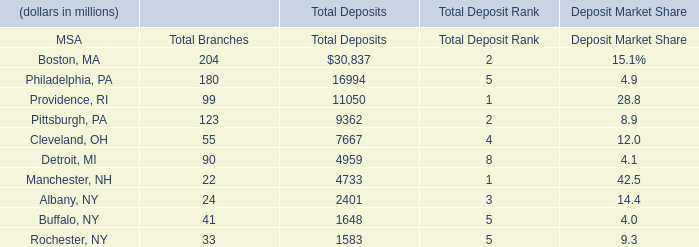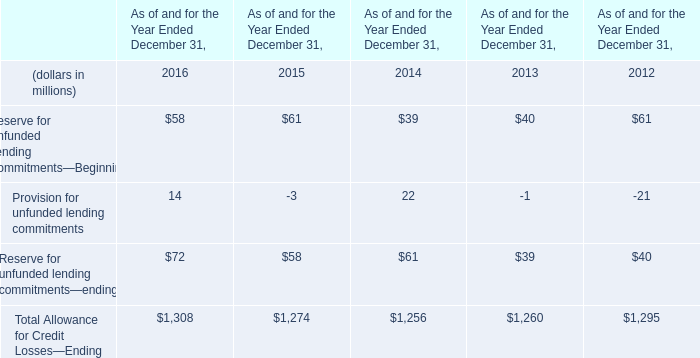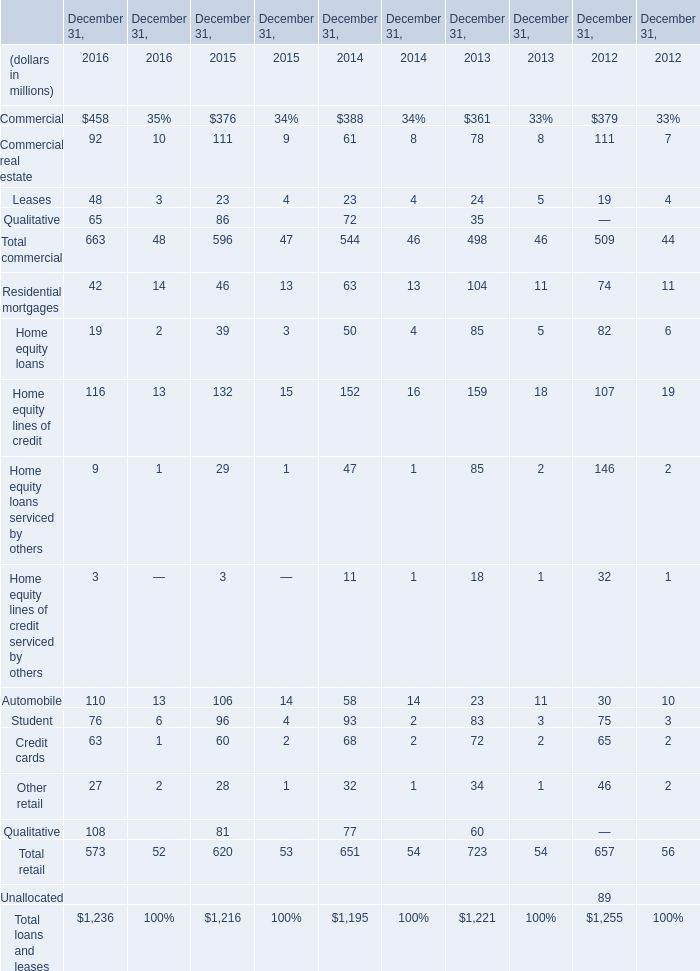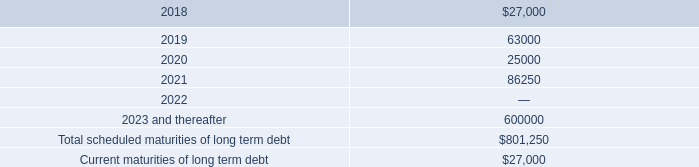what is the percentage change in the balance of outstanding loan from 2016 to 2017? 
Computations: ((42.0 - 40.0) / 40.0)
Answer: 0.05. 